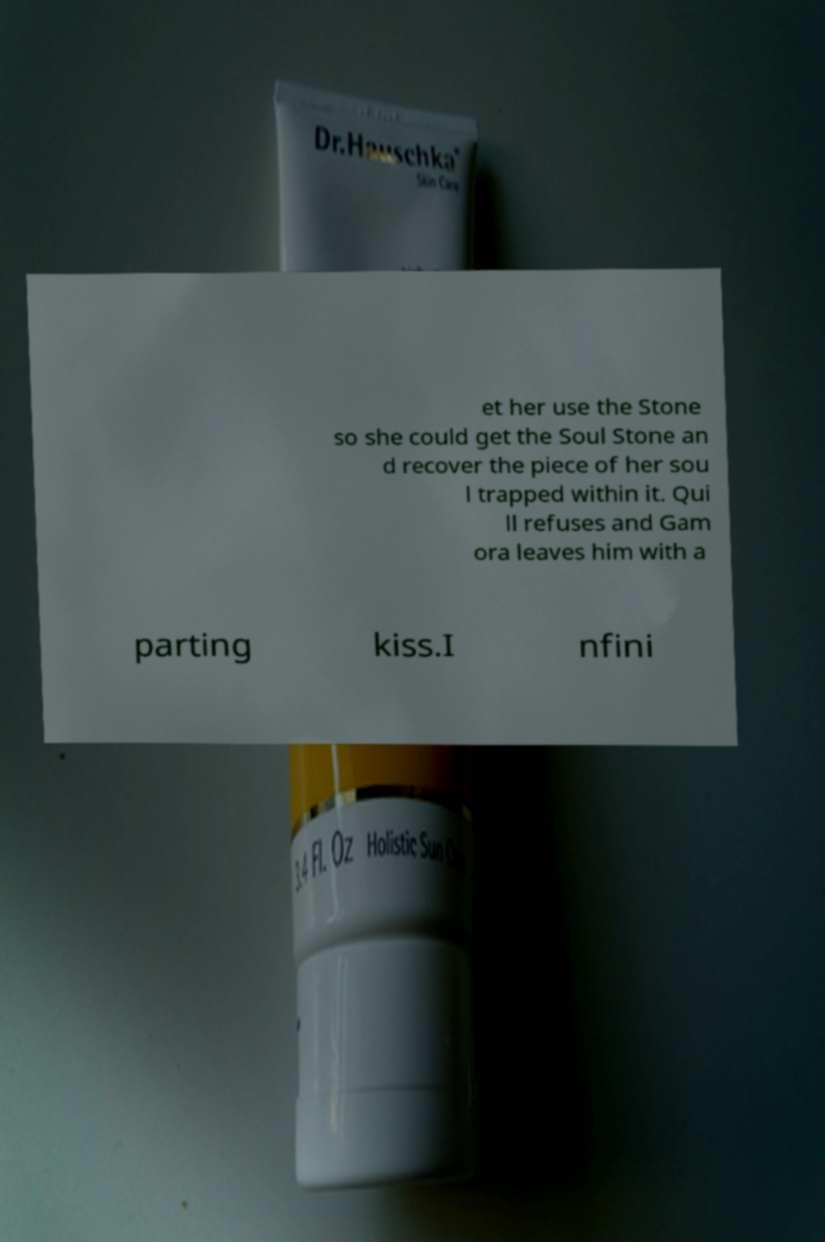What messages or text are displayed in this image? I need them in a readable, typed format. et her use the Stone so she could get the Soul Stone an d recover the piece of her sou l trapped within it. Qui ll refuses and Gam ora leaves him with a parting kiss.I nfini 